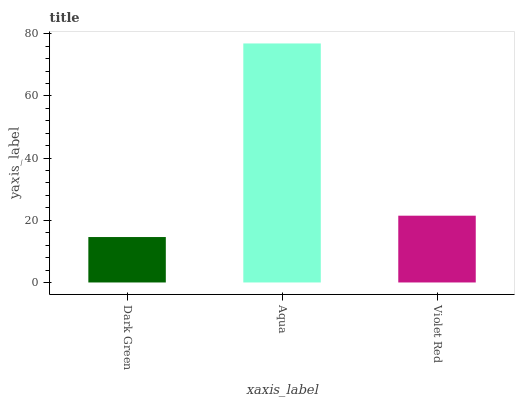Is Dark Green the minimum?
Answer yes or no. Yes. Is Aqua the maximum?
Answer yes or no. Yes. Is Violet Red the minimum?
Answer yes or no. No. Is Violet Red the maximum?
Answer yes or no. No. Is Aqua greater than Violet Red?
Answer yes or no. Yes. Is Violet Red less than Aqua?
Answer yes or no. Yes. Is Violet Red greater than Aqua?
Answer yes or no. No. Is Aqua less than Violet Red?
Answer yes or no. No. Is Violet Red the high median?
Answer yes or no. Yes. Is Violet Red the low median?
Answer yes or no. Yes. Is Aqua the high median?
Answer yes or no. No. Is Aqua the low median?
Answer yes or no. No. 